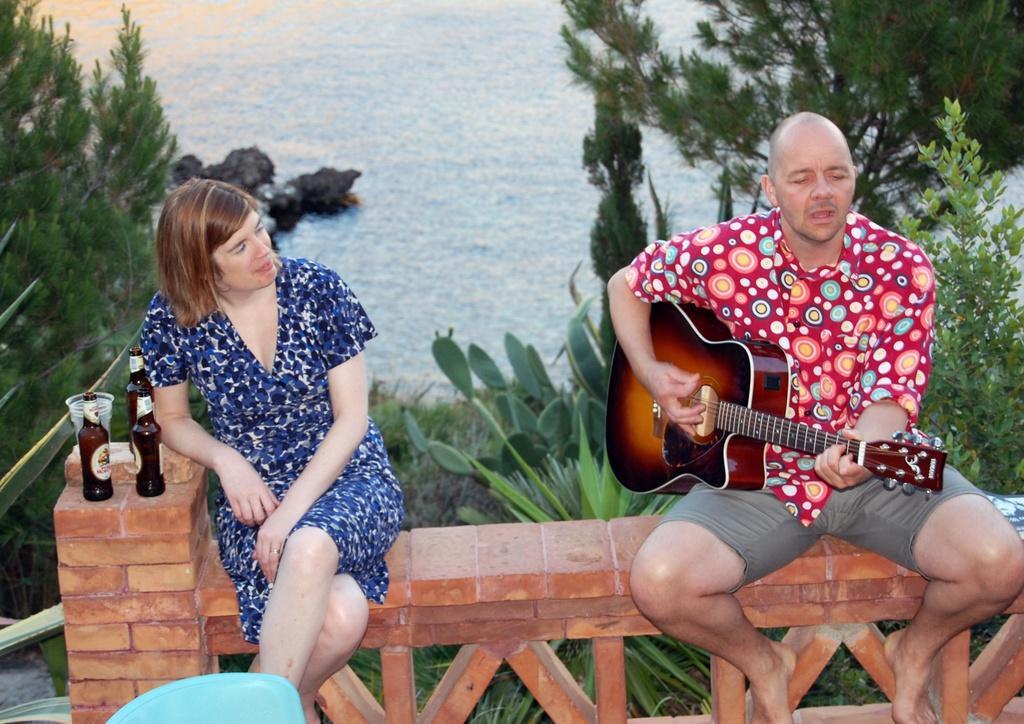Could you give a brief overview of what you see in this image? In this image i can see a man in red shirt and grey short is sitting on the bench and holding a guitar, to the left of the image i can see a woman in blue dress is sitting on a bench. i can see 3 glass bottles and few plastic glasses. In the background i can see few trees and water. 